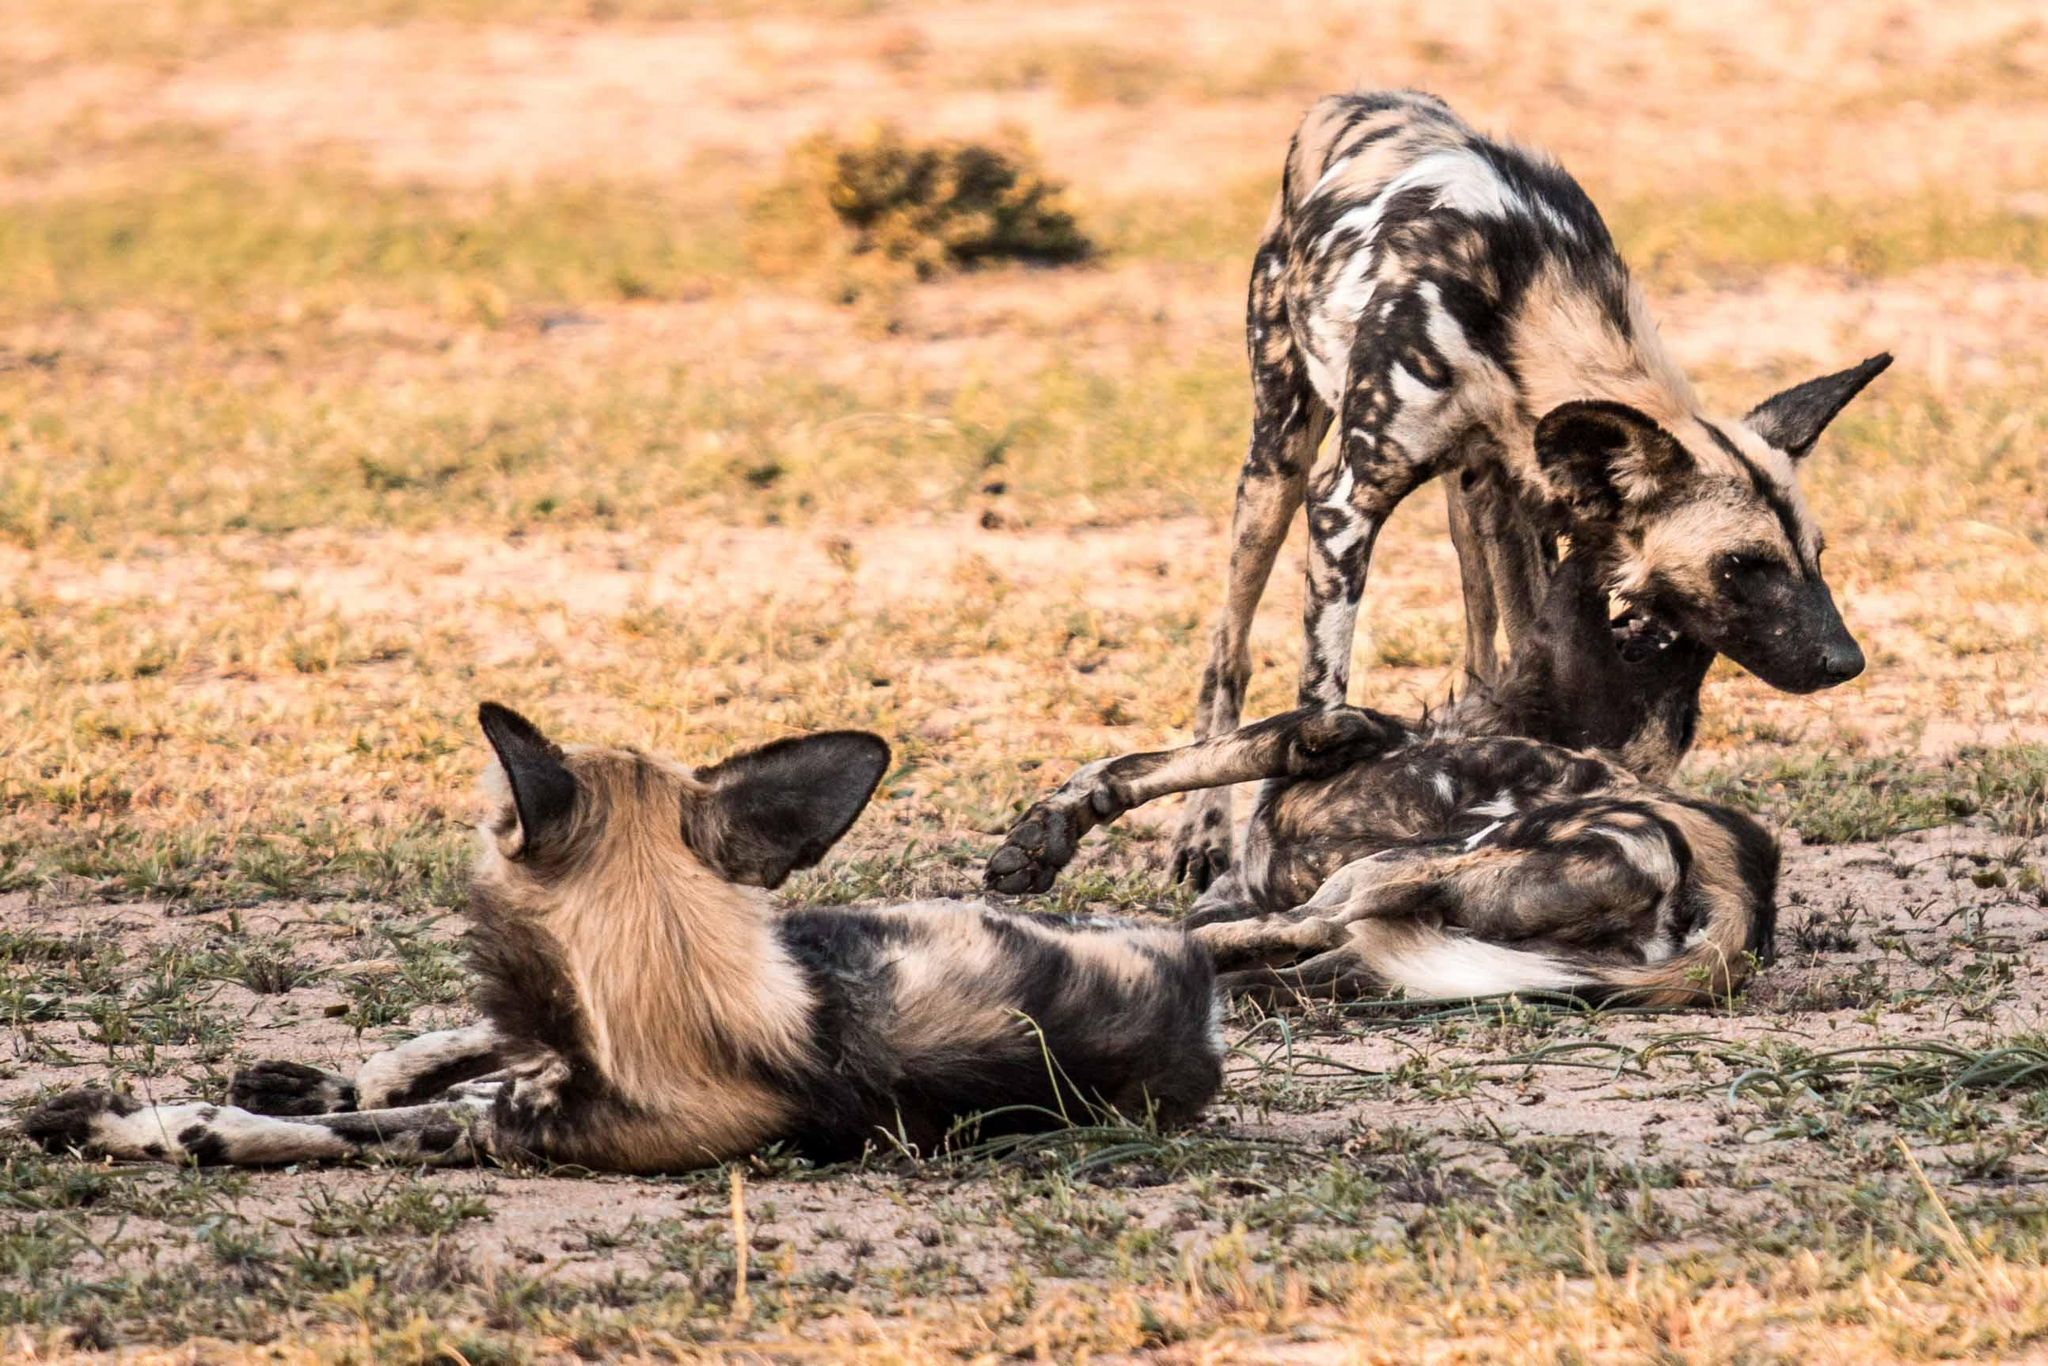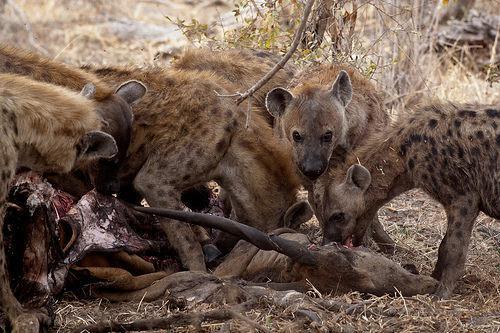The first image is the image on the left, the second image is the image on the right. For the images shown, is this caption "Multiple hyena are standing behind a carcass with the horn of a hooved animal in front of them, including a leftward-turned hyena with its mouth lowered to the carcass." true? Answer yes or no. Yes. The first image is the image on the left, the second image is the image on the right. Assess this claim about the two images: "In the image to the right, there are at least four hyenas.". Correct or not? Answer yes or no. Yes. 